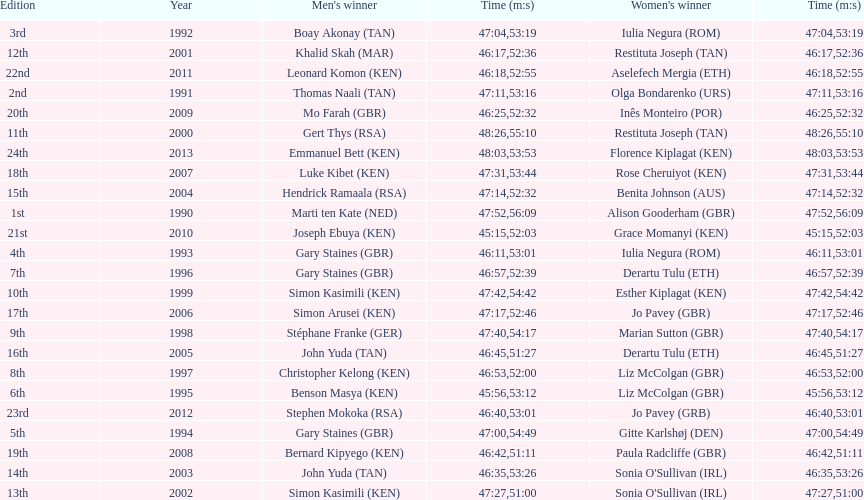How long did sonia o'sullivan take to finish in 2003? 53:26. 